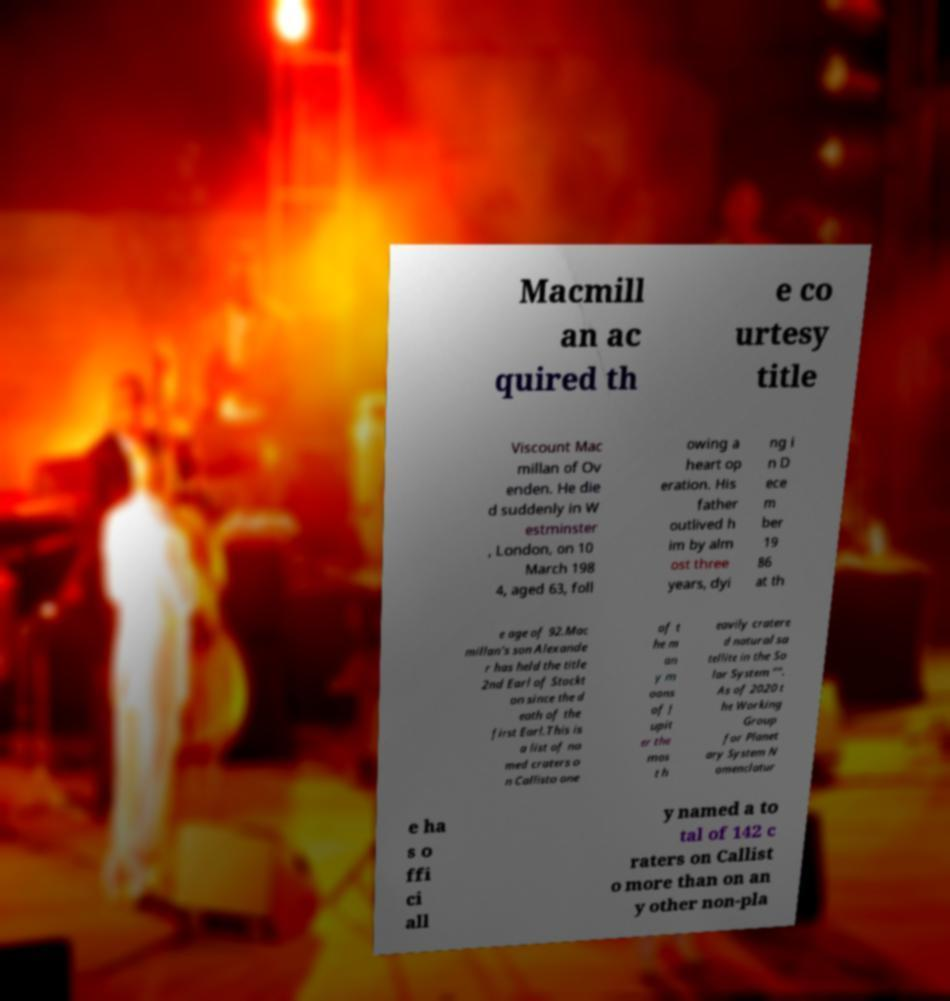Could you assist in decoding the text presented in this image and type it out clearly? Macmill an ac quired th e co urtesy title Viscount Mac millan of Ov enden. He die d suddenly in W estminster , London, on 10 March 198 4, aged 63, foll owing a heart op eration. His father outlived h im by alm ost three years, dyi ng i n D ece m ber 19 86 at th e age of 92.Mac millan's son Alexande r has held the title 2nd Earl of Stockt on since the d eath of the first Earl.This is a list of na med craters o n Callisto one of t he m an y m oons of J upit er the mos t h eavily cratere d natural sa tellite in the So lar System "". As of 2020 t he Working Group for Planet ary System N omenclatur e ha s o ffi ci all y named a to tal of 142 c raters on Callist o more than on an y other non-pla 